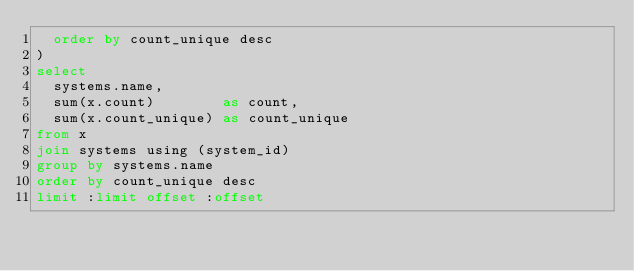<code> <loc_0><loc_0><loc_500><loc_500><_SQL_>	order by count_unique desc
)
select
	systems.name,
	sum(x.count)        as count,
	sum(x.count_unique) as count_unique
from x
join systems using (system_id)
group by systems.name
order by count_unique desc
limit :limit offset :offset
</code> 